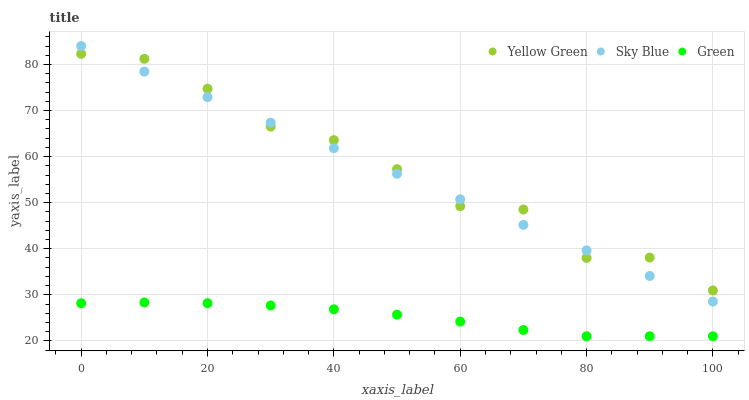Does Green have the minimum area under the curve?
Answer yes or no. Yes. Does Yellow Green have the maximum area under the curve?
Answer yes or no. Yes. Does Yellow Green have the minimum area under the curve?
Answer yes or no. No. Does Green have the maximum area under the curve?
Answer yes or no. No. Is Sky Blue the smoothest?
Answer yes or no. Yes. Is Yellow Green the roughest?
Answer yes or no. Yes. Is Green the smoothest?
Answer yes or no. No. Is Green the roughest?
Answer yes or no. No. Does Green have the lowest value?
Answer yes or no. Yes. Does Yellow Green have the lowest value?
Answer yes or no. No. Does Sky Blue have the highest value?
Answer yes or no. Yes. Does Yellow Green have the highest value?
Answer yes or no. No. Is Green less than Sky Blue?
Answer yes or no. Yes. Is Yellow Green greater than Green?
Answer yes or no. Yes. Does Yellow Green intersect Sky Blue?
Answer yes or no. Yes. Is Yellow Green less than Sky Blue?
Answer yes or no. No. Is Yellow Green greater than Sky Blue?
Answer yes or no. No. Does Green intersect Sky Blue?
Answer yes or no. No. 